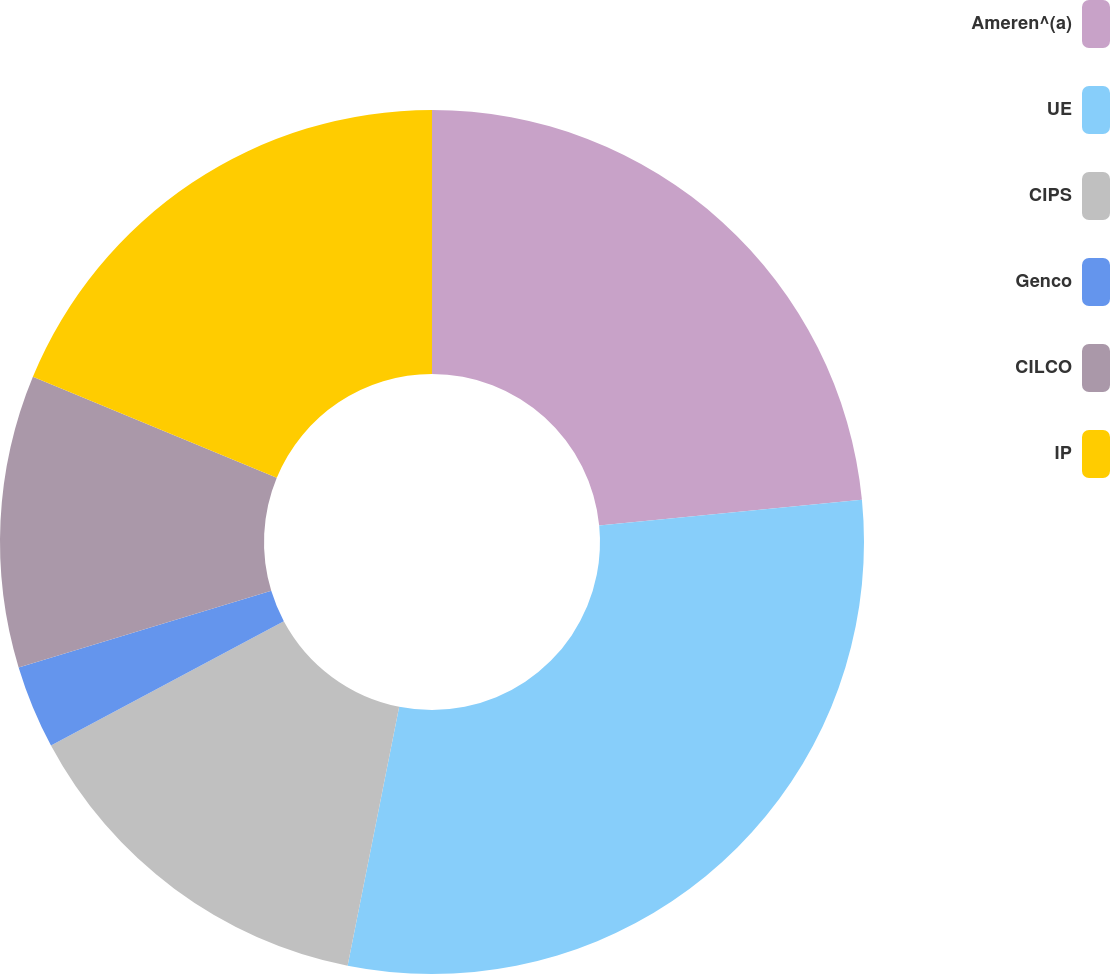Convert chart to OTSL. <chart><loc_0><loc_0><loc_500><loc_500><pie_chart><fcel>Ameren^(a)<fcel>UE<fcel>CIPS<fcel>Genco<fcel>CILCO<fcel>IP<nl><fcel>23.44%<fcel>29.69%<fcel>14.06%<fcel>3.12%<fcel>10.94%<fcel>18.75%<nl></chart> 